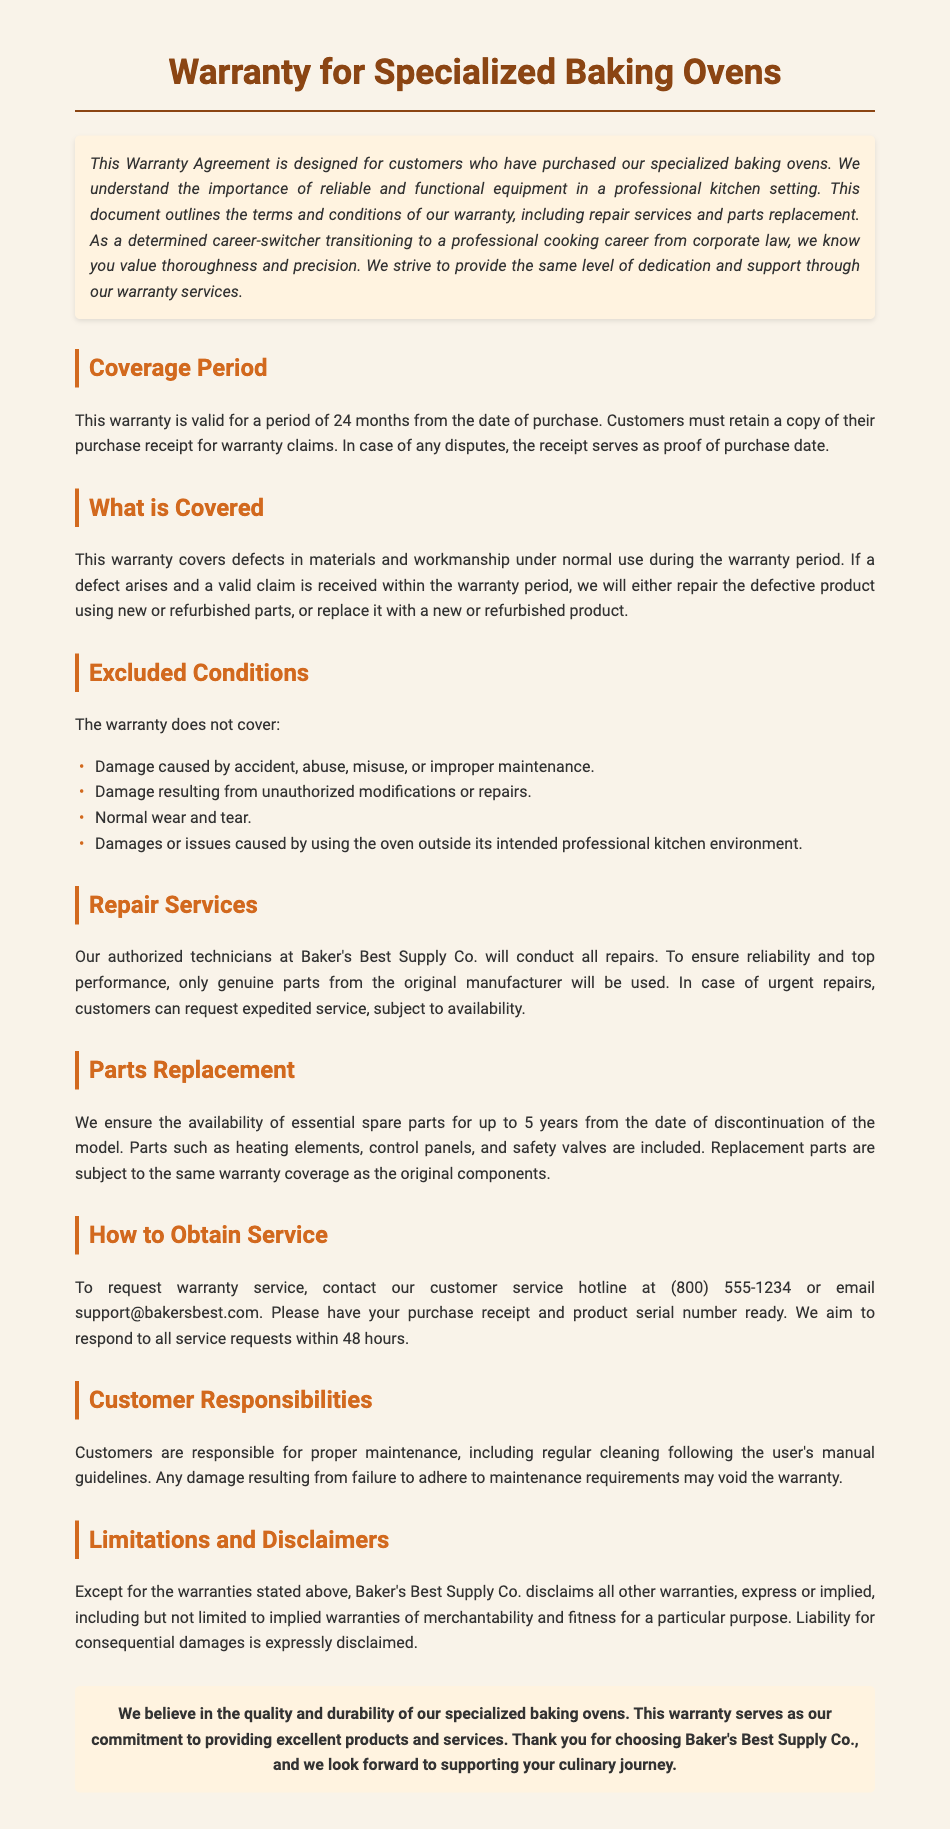What is the coverage period of the warranty? The warranty is valid for a period of 24 months from the date of purchase.
Answer: 24 months What must customers retain for warranty claims? Customers must retain a copy of their purchase receipt for warranty claims.
Answer: Purchase receipt Who conducts the repairs under the warranty? All repairs are conducted by authorized technicians at Baker's Best Supply Co.
Answer: Authorized technicians What types of damages are excluded from the warranty? The warranty excludes damage caused by accident, abuse, misuse, or improper maintenance.
Answer: Accident, abuse, misuse, improper maintenance What is the customer service hotline number? Customers are advised to contact customer service at (800) 555-1234.
Answer: (800) 555-1234 How long are essential spare parts available after model discontinuation? Essential spare parts are available for up to 5 years from the date of discontinuation of the model.
Answer: 5 years What type of warranty does Baker's Best Supply Co. not cover? Baker's Best Supply Co. disclaims all other warranties, express or implied.
Answer: All other warranties What do customers need to have ready when requesting service? Customers need to have their purchase receipt and product serial number ready.
Answer: Purchase receipt and product serial number 